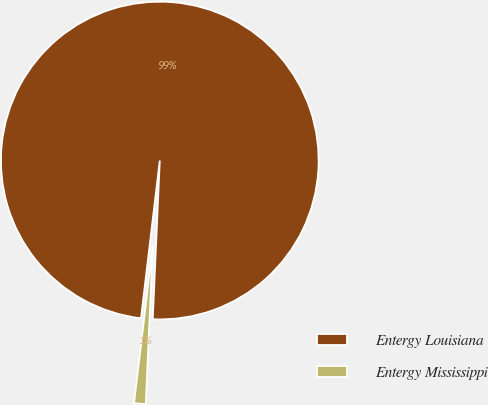Convert chart. <chart><loc_0><loc_0><loc_500><loc_500><pie_chart><fcel>Entergy Louisiana<fcel>Entergy Mississippi<nl><fcel>98.82%<fcel>1.18%<nl></chart> 